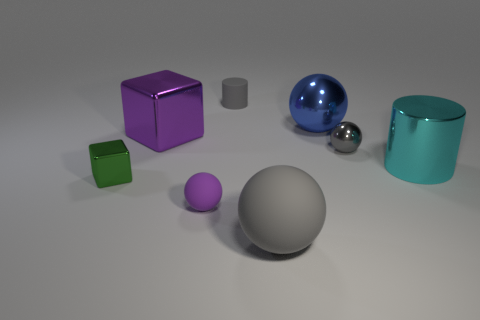There is a metallic thing that is both to the left of the large gray object and behind the large cyan metal object; what size is it?
Provide a short and direct response. Large. There is a small green thing; what shape is it?
Your response must be concise. Cube. How many things are either small red rubber cubes or purple objects that are in front of the large cyan cylinder?
Keep it short and to the point. 1. Do the tiny matte object behind the purple cube and the tiny metallic ball have the same color?
Your answer should be compact. Yes. What is the color of the matte object that is left of the big gray rubber sphere and in front of the tiny metal block?
Offer a very short reply. Purple. There is a big ball behind the tiny gray ball; what material is it?
Provide a short and direct response. Metal. What is the size of the metal cylinder?
Provide a short and direct response. Large. What number of yellow objects are tiny things or objects?
Offer a very short reply. 0. What is the size of the rubber thing that is on the left side of the gray thing behind the big blue ball?
Ensure brevity in your answer.  Small. Is the color of the large shiny cylinder the same as the metallic block behind the small green metal cube?
Your answer should be compact. No. 